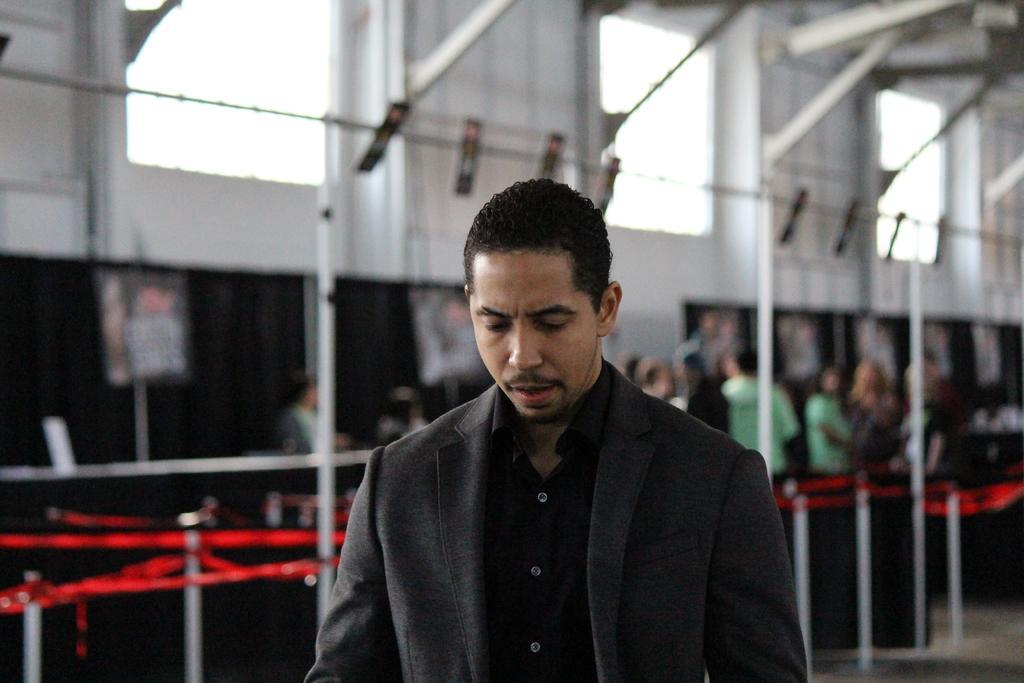Could you give a brief overview of what you see in this image? In the picture I can see people among them the man in the front is wearing a coat and a shirt. In the background I can see poles, windows and some other objects. The background of the image is blurred. 